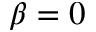Convert formula to latex. <formula><loc_0><loc_0><loc_500><loc_500>\beta = 0</formula> 